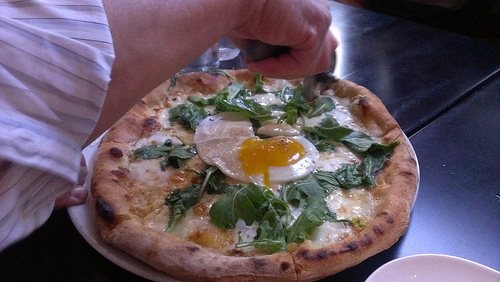Is he to the right or to the left of the cheese that is in the bottom of the photo? He is positioned to the left of the cheese at the bottom of the photo. 